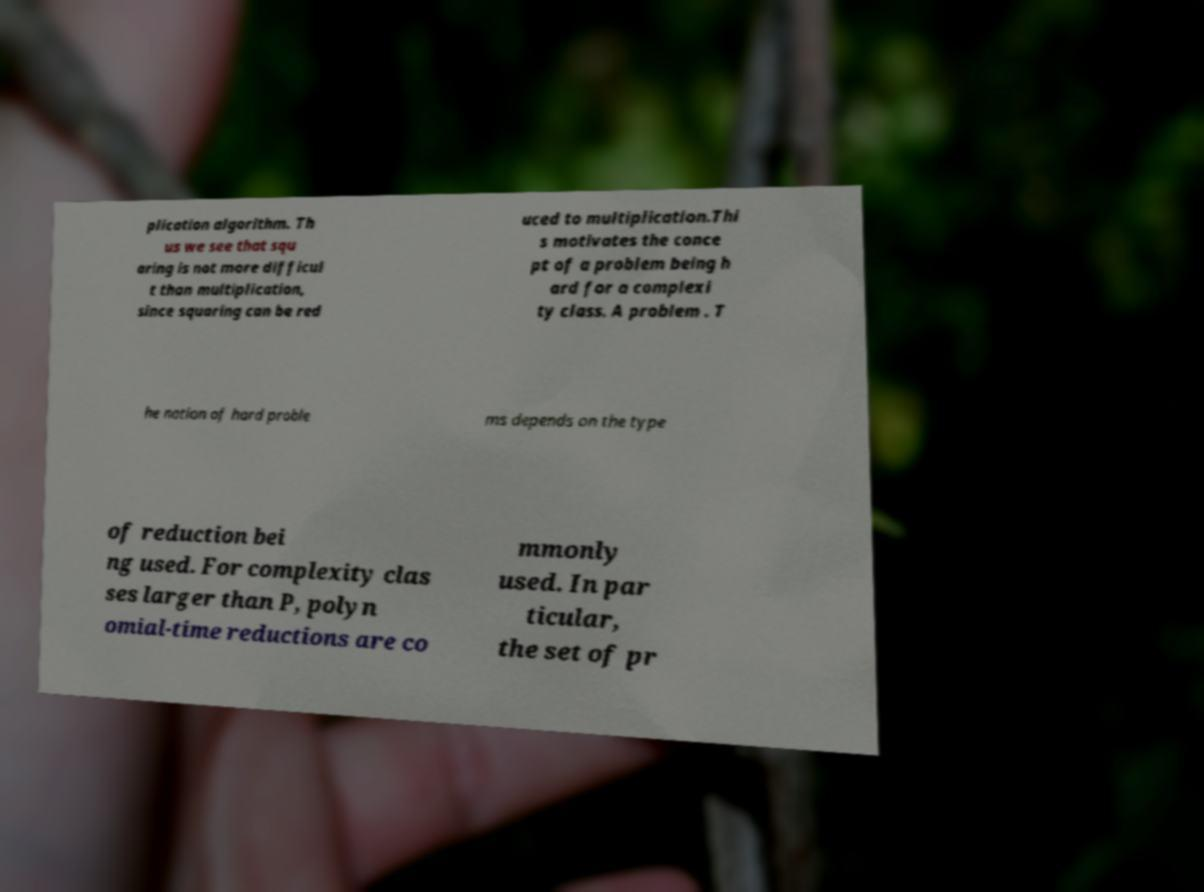What messages or text are displayed in this image? I need them in a readable, typed format. plication algorithm. Th us we see that squ aring is not more difficul t than multiplication, since squaring can be red uced to multiplication.Thi s motivates the conce pt of a problem being h ard for a complexi ty class. A problem . T he notion of hard proble ms depends on the type of reduction bei ng used. For complexity clas ses larger than P, polyn omial-time reductions are co mmonly used. In par ticular, the set of pr 